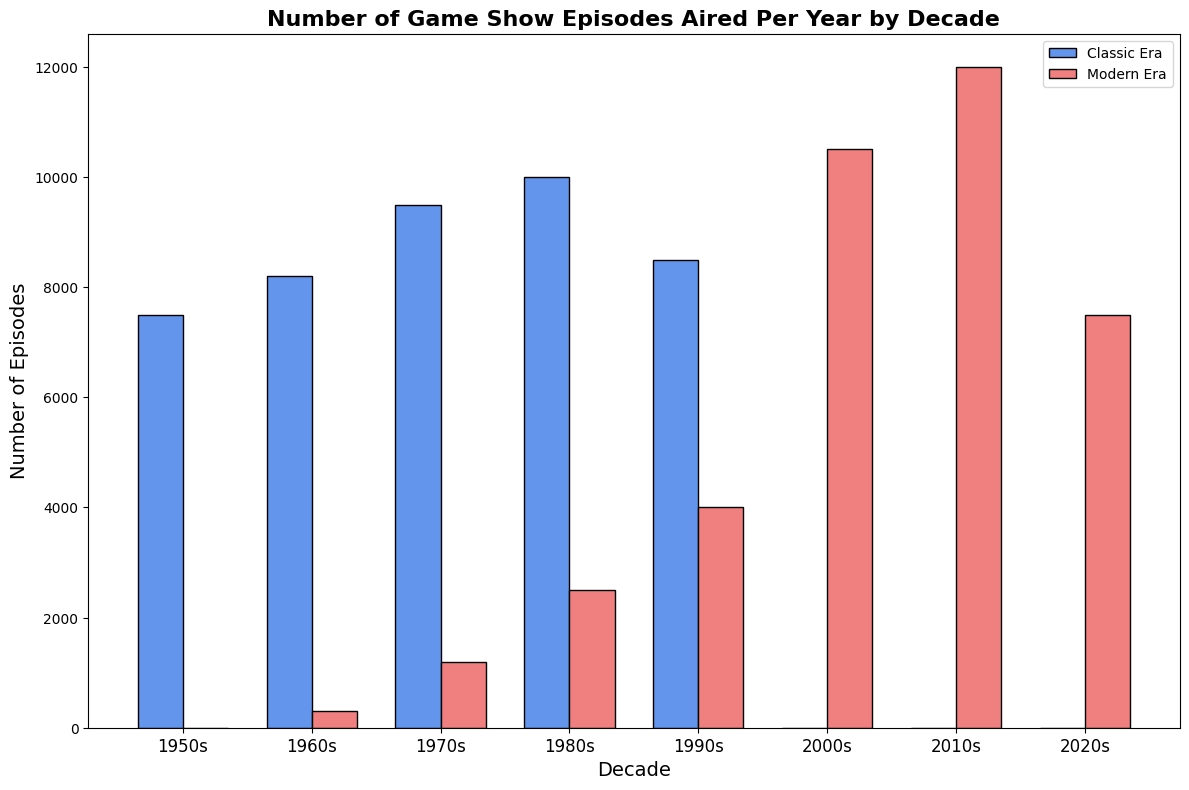Which decade had the most episodes aired during the Classic Era? To determine this, look at the height of the bars for the Classic Era. The highest bar represents the decade with the most episodes. The 1980s has the highest bar for the Classic Era.
Answer: 1980s Which era had more episodes aired in the 2000s? Compare the heights of the bars in the 2000s for both eras. The Modern Era has a bar while the Classic Era has no bar, indicating more episodes aired in the Modern Era.
Answer: Modern Era By how much did the number of episodes aired in the Classic Era change from the 1970s to the 1980s? Subtract the number of episodes in the 1970s from the number of episodes in the 1980s. The calculation is 10000 - 9500 = 500.
Answer: 500 What is the total number of episodes aired in the Modern Era from the 2000s to the 2020s? Add the number of episodes from the 2000s, 2010s, and 2020s for the Modern Era. The calculation is 10500 + 12000 + 7500 = 30000.
Answer: 30000 Which decade showed the greatest disparity between the Classic and Modern Eras? Calculate the absolute difference between the number of episodes in the Classic and Modern Eras for each decade and identify the largest difference. The 1980s have a Classic Era bar at 10000 and a Modern Era bar at 2500, resulting in a difference of 7500, which is the greatest disparity.
Answer: 1980s Compare the total number of episodes aired in the Classic Era to those in the Modern Era for the 1960s. Which is higher? Look at the bars for the 1960s and add the numbers. The Classic Era has 8200 and the Modern Era has 300, making the Classic Era higher.
Answer: Classic Era What is the average number of episodes aired in the 1990s across both eras? Add the number of episodes from both eras in the 1990s and divide by two. The calculation is (8500 + 4000) / 2 = 6250.
Answer: 6250 How many more episodes were aired in the Modern Era in the 2010s compared to the 2000s? Subtract the number of episodes in the 2000s from the 2010s in the Modern Era. The calculation is 12000 - 10500 = 1500.
Answer: 1500 Which decade shows the largest number of episodes aired in the Modern Era? Identify the tallest bar in the Modern Era. The tallest bar is in the 2010s, with 12000 episodes.
Answer: 2010s 